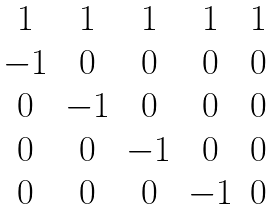Convert formula to latex. <formula><loc_0><loc_0><loc_500><loc_500>\begin{matrix} 1 & 1 & 1 & 1 & 1 \\ - 1 & 0 & 0 & 0 & 0 \\ 0 & - 1 & 0 & 0 & 0 \\ 0 & 0 & - 1 & 0 & 0 \\ 0 & 0 & 0 & - 1 & 0 \end{matrix}</formula> 